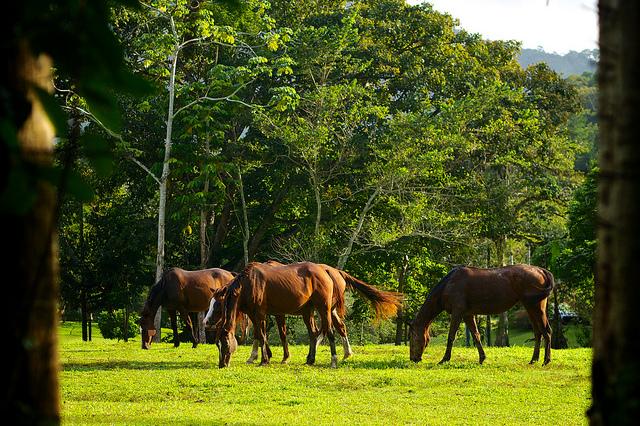How many animals are in this scene?
Keep it brief. 3. What color are the horses?
Concise answer only. Brown. How many horses are there?
Write a very short answer. 3. How many horses are in the field?
Answer briefly. 3. 